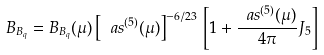<formula> <loc_0><loc_0><loc_500><loc_500>B _ { B _ { q } } = B _ { B _ { q } } ( \mu ) \left [ \ a s ^ { ( 5 ) } ( \mu ) \right ] ^ { - 6 / 2 3 } \, \left [ 1 + \frac { \ a s ^ { ( 5 ) } ( \mu ) } { 4 \pi } J _ { 5 } \right ]</formula> 